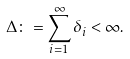Convert formula to latex. <formula><loc_0><loc_0><loc_500><loc_500>\Delta \colon = \sum _ { i = 1 } ^ { \infty } \delta _ { i } < \infty .</formula> 